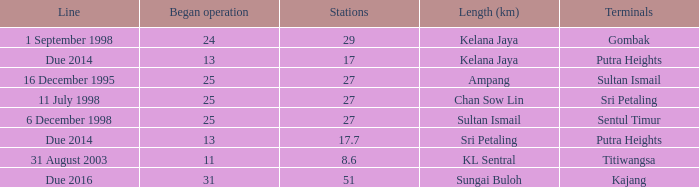What is the average operation beginning with a length of ampang and over 27 stations? None. 